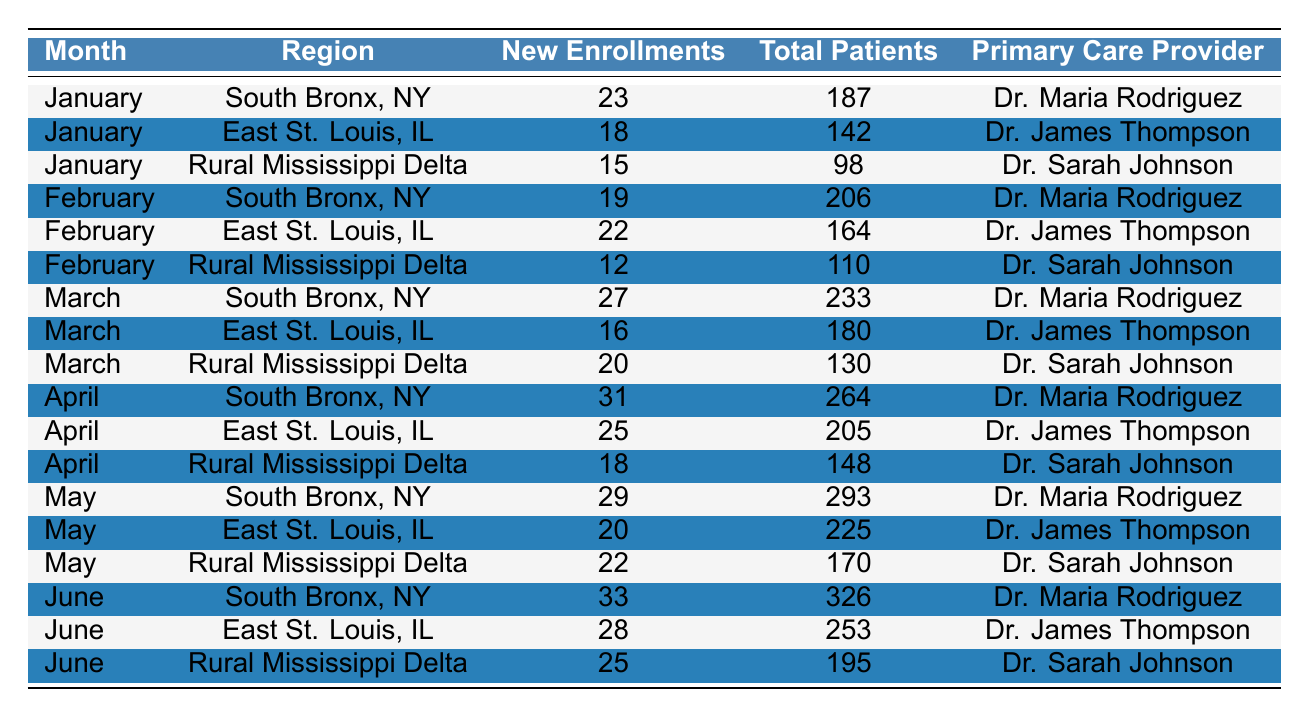What is the total number of new enrollments in the South Bronx for the first six months? Adding up the new enrollments in the South Bronx for each month: 23 (January) + 19 (February) + 27 (March) + 31 (April) + 29 (May) + 33 (June) = 162
Answer: 162 Which region had the highest new enrollments in May? In May, the South Bronx had 29 new enrollments, East St. Louis had 20, and Rural Mississippi Delta had 22. The South Bronx had the highest at 29.
Answer: South Bronx How many total patients were enrolled in East St. Louis by the end of June? The total number of patients in East St. Louis are: 142 (January) + 164 (February) + 180 (March) + 205 (April) + 225 (May) + 253 (June) = 1,169 (However, this is not reflecting total across months, it's the June total patients directly provided which is 253)
Answer: 253 What is the average number of new enrollments across all regions for April? Sum the new enrollments in April: 31 (South Bronx) + 25 (East St. Louis) + 18 (Rural Mississippi Delta) = 74. Divide that by the number of regions: 74/3 = 24.67.
Answer: 24.67 Did the total number of patients in the Rural Mississippi Delta increase every month from January to June? Check the total patients for each month: 98 (January), 110 (February), 130 (March), 148 (April), 170 (May), 195 (June). Each month shows an increase, confirming the total patients increased every month.
Answer: Yes Which primary care provider served the most new enrollments overall from January to June? By counting new enrollments: Dr. Maria Rodriguez (South Bronx) had 23+19+27+31+29+33 = 162, Dr. James Thompson (East St. Louis) had 18+22+16+25+20+28 = 129, and Dr. Sarah Johnson (Rural Mississippi Delta) had 15+12+20+18+22+25 = 112. Dr. Maria Rodriguez had the most at 162.
Answer: Dr. Maria Rodriguez What is the percentage increase in new enrollments from January to June in the South Bronx? New enrollments increased from 23 (January) to 33 (June). The increase is 33 - 23 = 10. The percentage increase is (10/23) * 100 = 43.48%.
Answer: 43.48% 